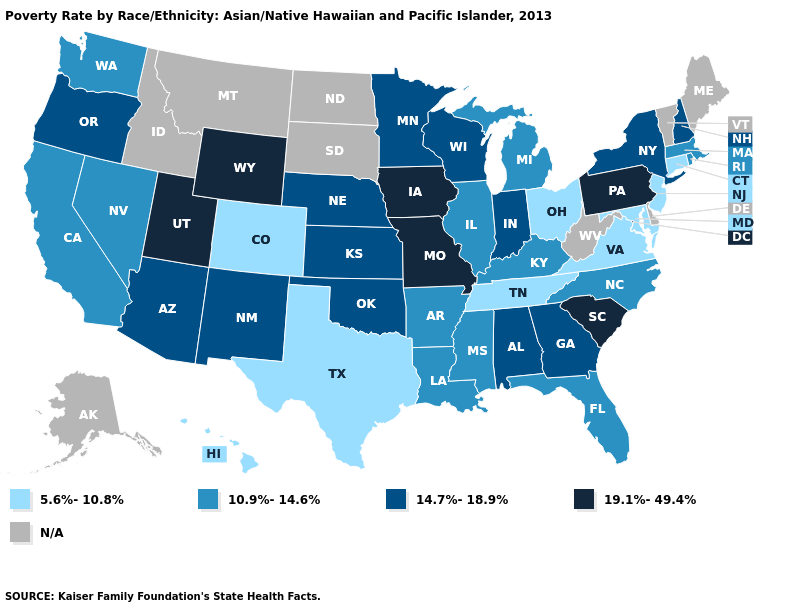Does Arkansas have the lowest value in the South?
Write a very short answer. No. Name the states that have a value in the range 10.9%-14.6%?
Give a very brief answer. Arkansas, California, Florida, Illinois, Kentucky, Louisiana, Massachusetts, Michigan, Mississippi, Nevada, North Carolina, Rhode Island, Washington. What is the value of Wisconsin?
Keep it brief. 14.7%-18.9%. Among the states that border Arkansas , does Texas have the highest value?
Be succinct. No. What is the value of Alaska?
Short answer required. N/A. What is the lowest value in the USA?
Write a very short answer. 5.6%-10.8%. What is the highest value in the USA?
Be succinct. 19.1%-49.4%. Which states hav the highest value in the South?
Short answer required. South Carolina. What is the value of Wyoming?
Write a very short answer. 19.1%-49.4%. What is the value of Minnesota?
Answer briefly. 14.7%-18.9%. What is the value of North Carolina?
Short answer required. 10.9%-14.6%. What is the value of Hawaii?
Write a very short answer. 5.6%-10.8%. Does the first symbol in the legend represent the smallest category?
Write a very short answer. Yes. What is the highest value in states that border Florida?
Keep it brief. 14.7%-18.9%. Name the states that have a value in the range 19.1%-49.4%?
Quick response, please. Iowa, Missouri, Pennsylvania, South Carolina, Utah, Wyoming. 